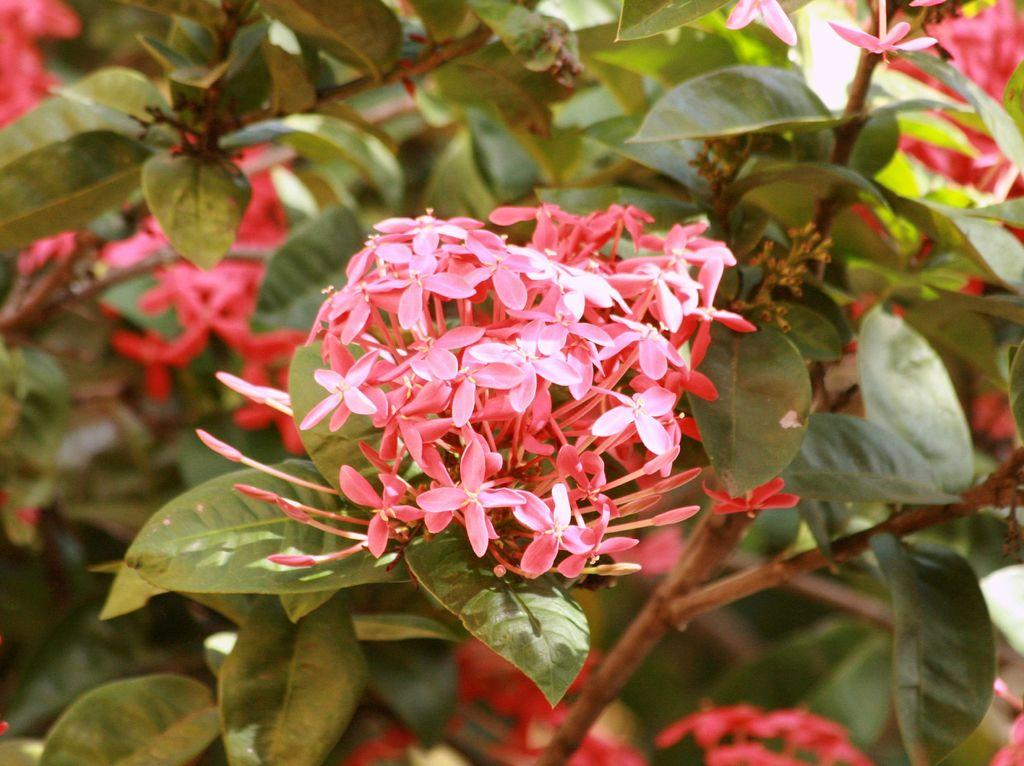What type of living organisms can be seen in the image? Plants and flowers are visible in the image. Can you describe the stage of growth for some of the plants in the image? There are buds in the image, which suggests that some of the plants are in the early stages of growth. What type of jail can be seen in the image? There is no jail present in the image; it features plants and flowers. How does the sleet affect the growth of the flowers in the image? There is no sleet present in the image, so its effect on the flowers cannot be determined. 